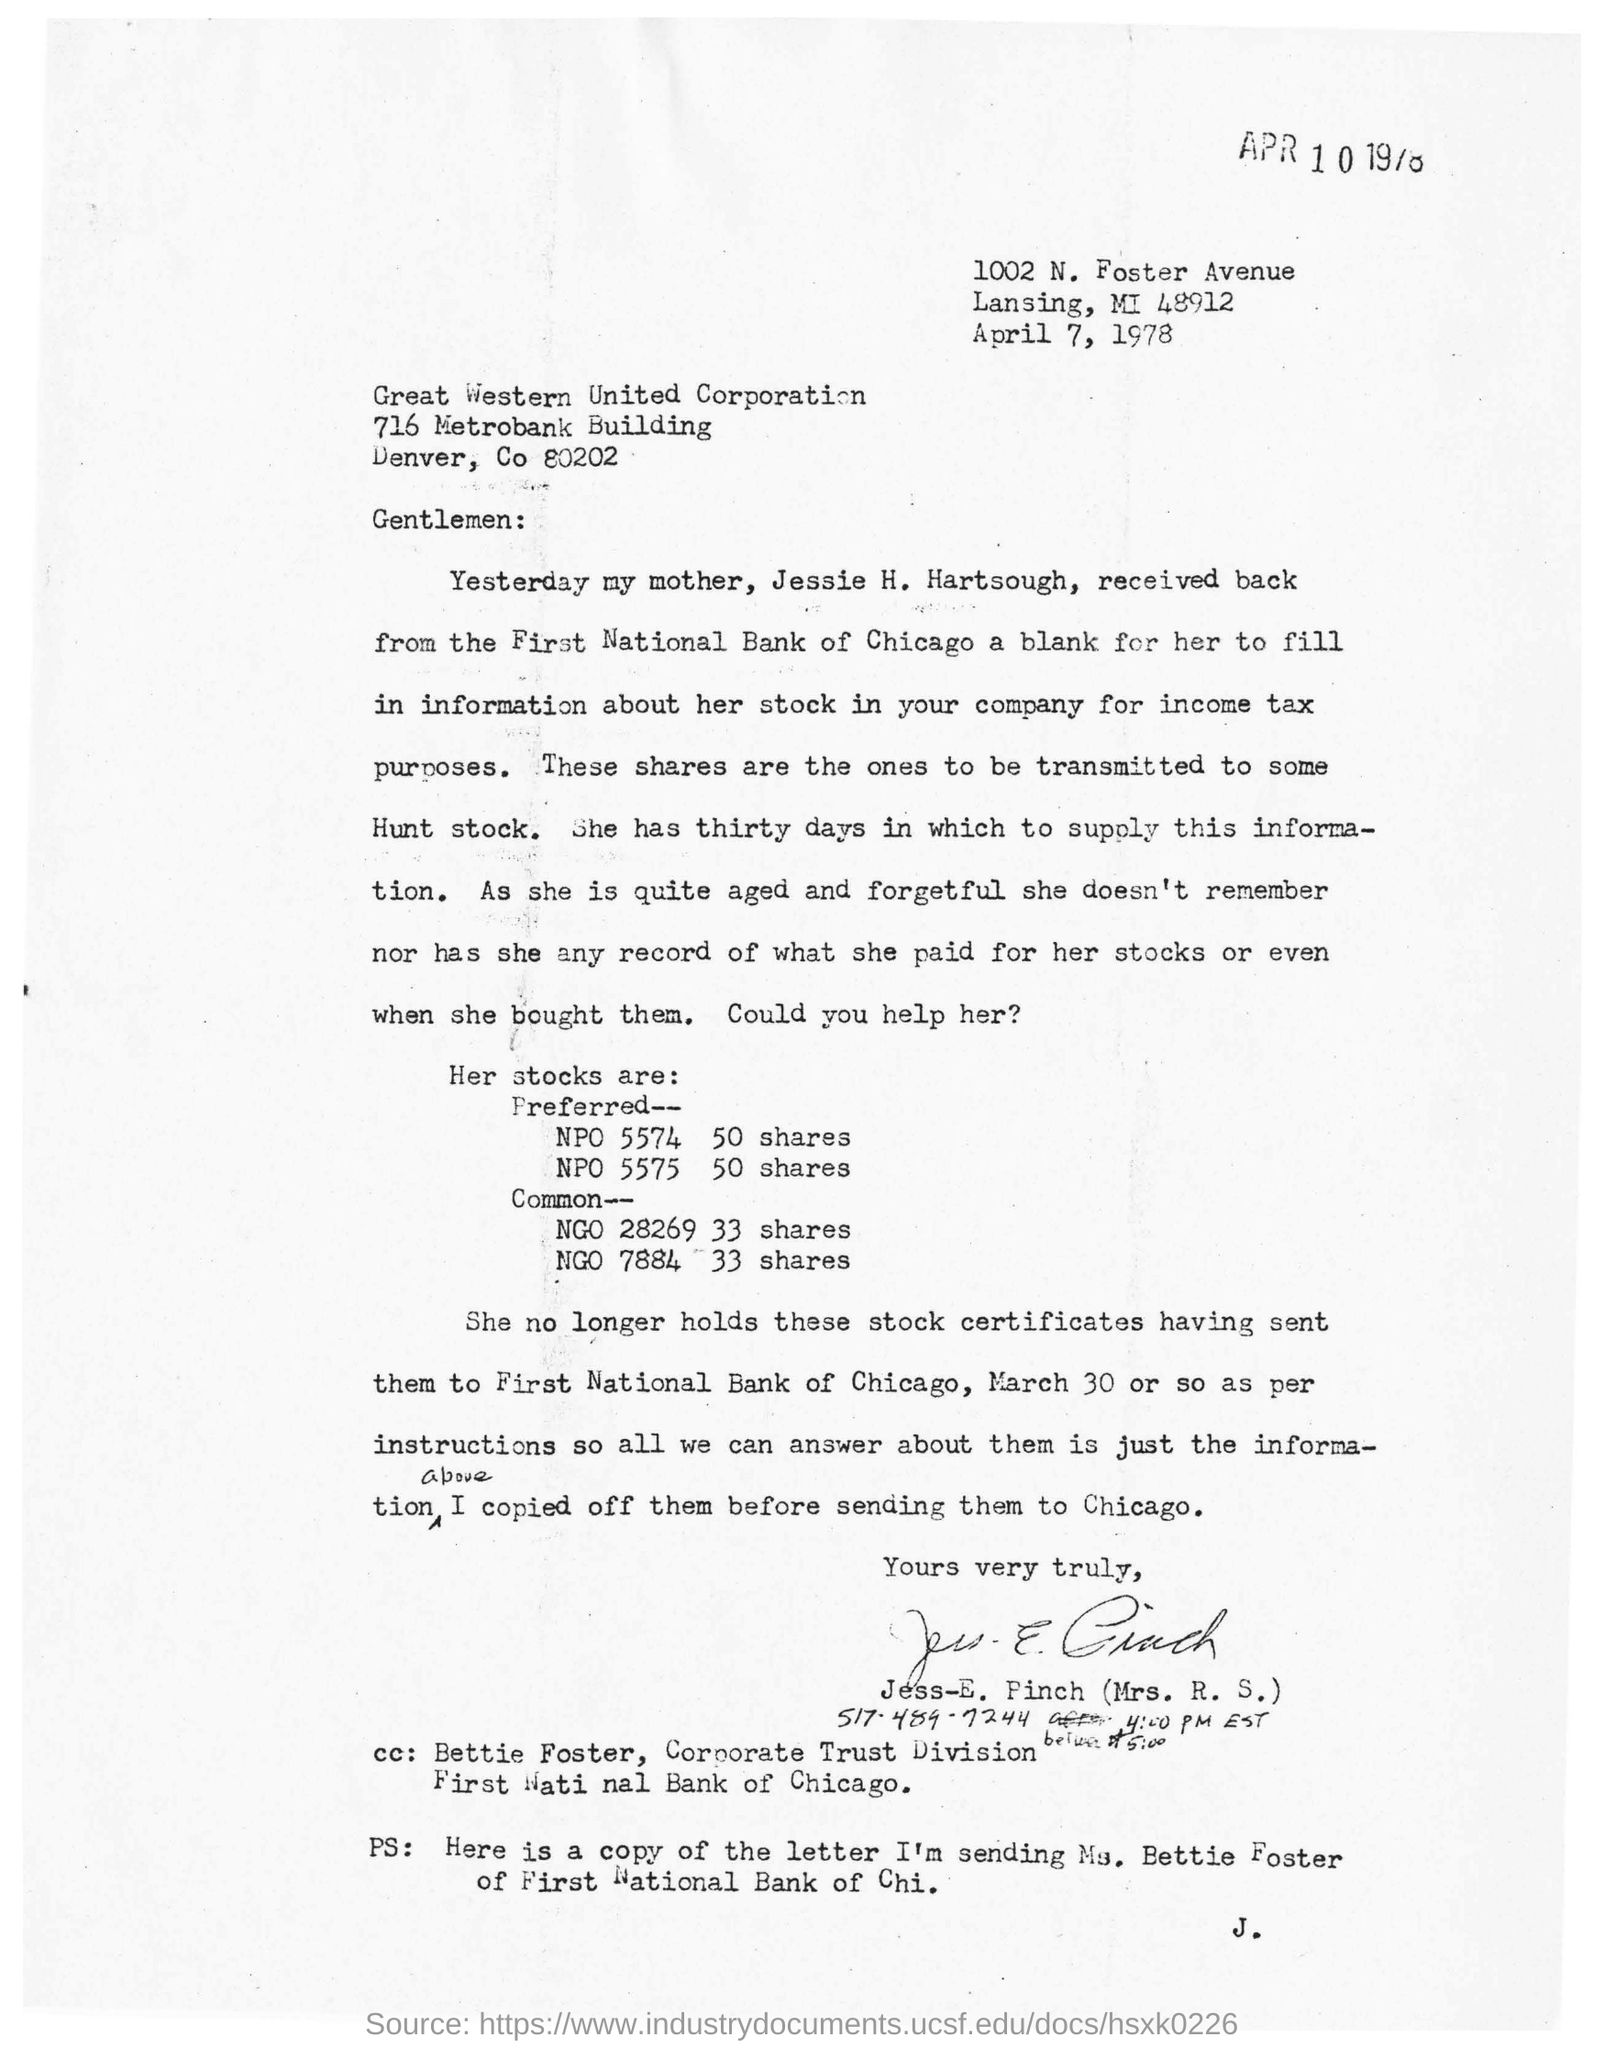Identify some key points in this picture. The letter is dated April 7, 1978. 